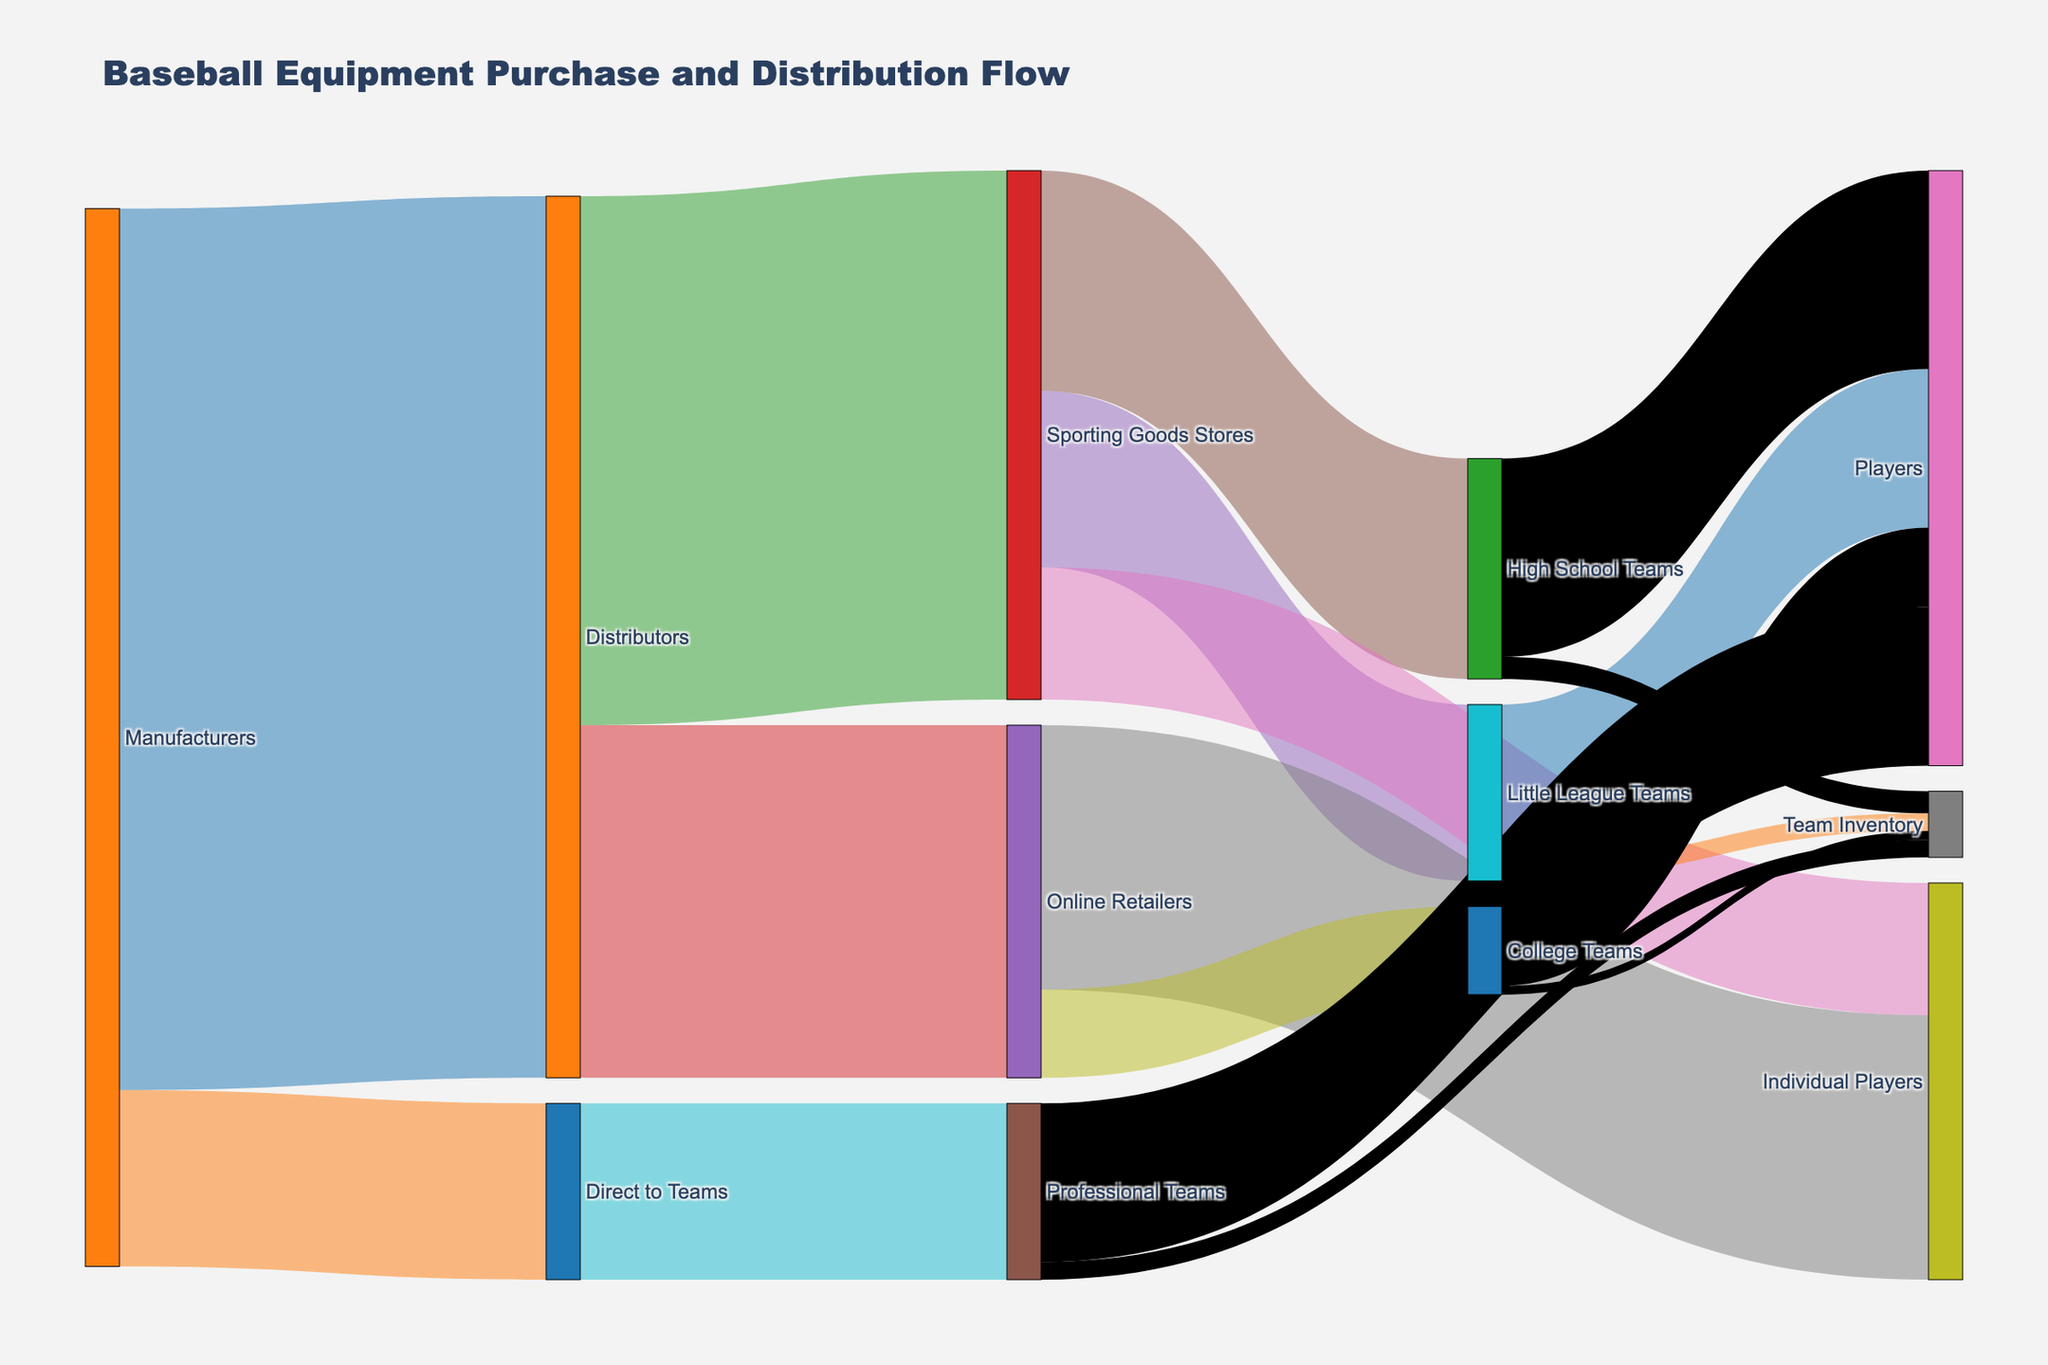What is the title of the figure? The title is usually at the top of the figure and describes the overall content.
Answer: Baseball Equipment Purchase and Distribution Flow How many total units of equipment do the Manufacturers distribute? Add the values distributed from Manufacturers to Distributors and Direct to Teams: 1,000,000 + 200,000 = 1,200,000
Answer: 1,200,000 Which group receives the most equipment from Online Retailers? Compare values: Individual Players receive 300,000, College Teams receive 100,000
Answer: Individual Players What is the combined amount of equipment received by Little League Teams and High School Teams from Sporting Goods Stores? Add the values: 200,000 (Little League Teams) + 250,000 (High School Teams) = 450,000
Answer: 450,000 How much equipment goes directly from Distributors to High School Teams? Check all connections from Distributors; High School Teams are not directly connected to Distributors.
Answer: 0 What is the total amount of equipment that ends up with Individual Players? Add values from Sporting Goods Stores (150,000), Online Retailers (300,000), Little League Teams (180,000), and High School Teams (225,000): 150,000 + 300,000 + 180,000 + 225,000 = 855,000
Answer: 855,000 Do Professional Teams receive more or less equipment than College Teams? Compare values: Professional Teams receive 200,000, College Teams receive 100,000
Answer: More Which flow pathway has the smallest distribution of equipment, and how much is it? Compare all values in the figure: College Teams' Team Inventory with 10,000 is the smallest.
Answer: College Teams' Team Inventory, 10,000 Calculate the difference in equipment received by Individual Players from Online Retailers versus Sporting Goods Stores. Subtract the value from Sporting Goods Stores (150,000) from Online Retailers (300,000): 300,000 - 150,000 = 150,000
Answer: 150,000 What percentage of the equipment distributed by Distributors goes to Sporting Goods Stores? Divide the value sent to Sporting Goods Stores (600,000) by the total from Distributors (1,000,000) and multiply by 100: (600,000 / 1,000,000) * 100 = 60%
Answer: 60% How much equipment is allocated to Team Inventory across all teams? Sum the Team Inventory values of Little League Teams (20,000), High School Teams (25,000), College Teams (10,000), and Professional Teams (20,000): 20,000 + 25,000 + 10,000 + 20,000 = 75,000
Answer: 75,000 